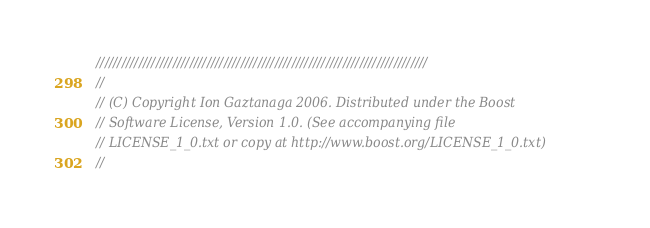Convert code to text. <code><loc_0><loc_0><loc_500><loc_500><_C++_>//////////////////////////////////////////////////////////////////////////////
//
// (C) Copyright Ion Gaztanaga 2006. Distributed under the Boost
// Software License, Version 1.0. (See accompanying file
// LICENSE_1_0.txt or copy at http://www.boost.org/LICENSE_1_0.txt)
//</code> 